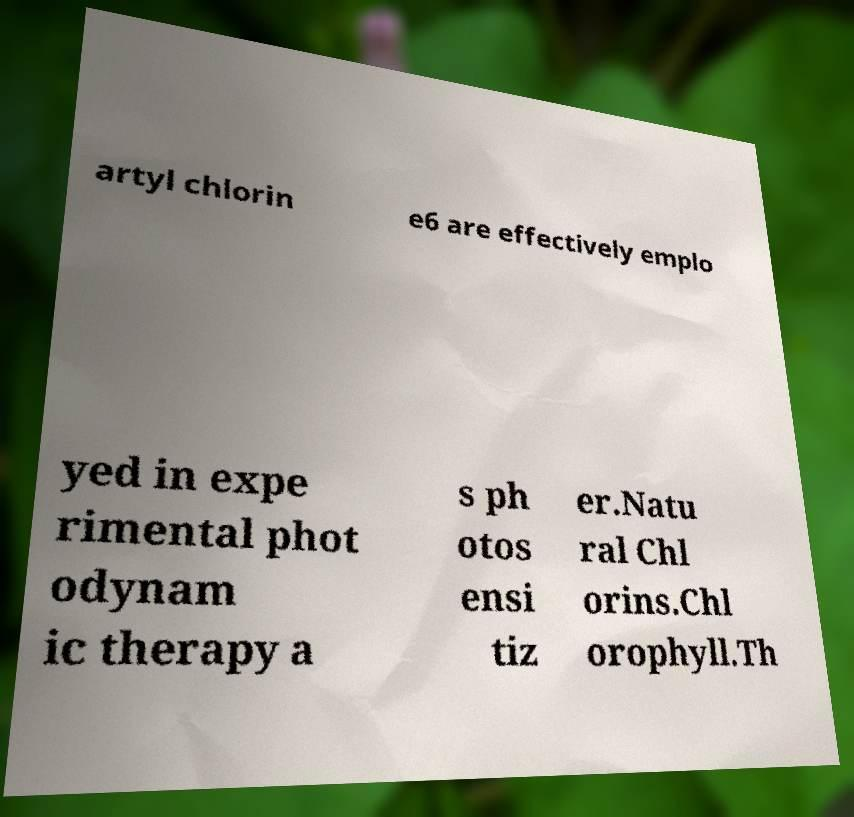What messages or text are displayed in this image? I need them in a readable, typed format. artyl chlorin e6 are effectively emplo yed in expe rimental phot odynam ic therapy a s ph otos ensi tiz er.Natu ral Chl orins.Chl orophyll.Th 